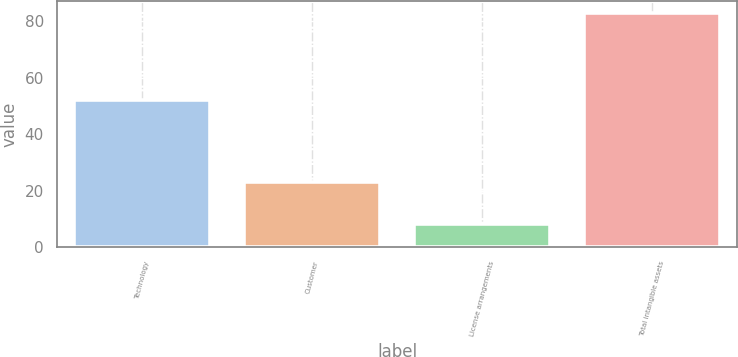<chart> <loc_0><loc_0><loc_500><loc_500><bar_chart><fcel>Technology<fcel>Customer<fcel>License arrangements<fcel>Total intangible assets<nl><fcel>52<fcel>23<fcel>8<fcel>83<nl></chart> 